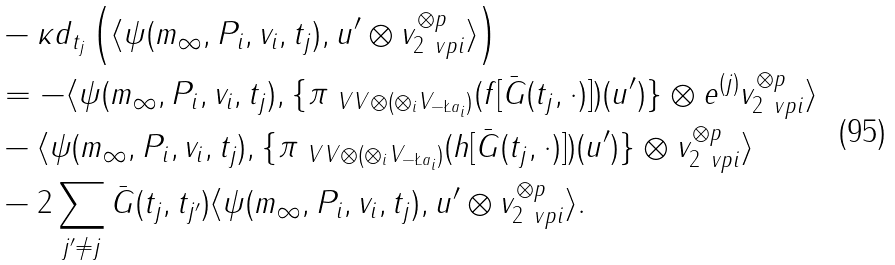<formula> <loc_0><loc_0><loc_500><loc_500>& - \kappa d _ { t _ { j } } \left ( \langle \psi ( m _ { \infty } , P _ { i } , v _ { i } , t _ { j } ) , u ^ { \prime } \otimes v _ { 2 \ v p i } ^ { \otimes p } \rangle \right ) \\ & = - \langle \psi ( m _ { \infty } , P _ { i } , v _ { i } , t _ { j } ) , \{ \pi _ { \ V V \otimes ( \otimes _ { i } V _ { - \L a _ { i } } ) } ( f [ \bar { G } ( t _ { j } , \cdot ) ] ) ( u ^ { \prime } ) \} \otimes e ^ { ( j ) } v _ { 2 \ v p i } ^ { \otimes p } \rangle \\ & - \langle \psi ( m _ { \infty } , P _ { i } , v _ { i } , t _ { j } ) , \{ \pi _ { \ V V \otimes ( \otimes _ { i } V _ { - \L a _ { i } } ) } ( h [ \bar { G } ( t _ { j } , \cdot ) ] ) ( u ^ { \prime } ) \} \otimes v _ { 2 \ v p i } ^ { \otimes p } \rangle \\ & - 2 \sum _ { j ^ { \prime } \neq j } \bar { G } ( t _ { j } , t _ { j ^ { \prime } } ) \langle \psi ( m _ { \infty } , P _ { i } , v _ { i } , t _ { j } ) , u ^ { \prime } \otimes v _ { 2 \ v p i } ^ { \otimes p } \rangle .</formula> 